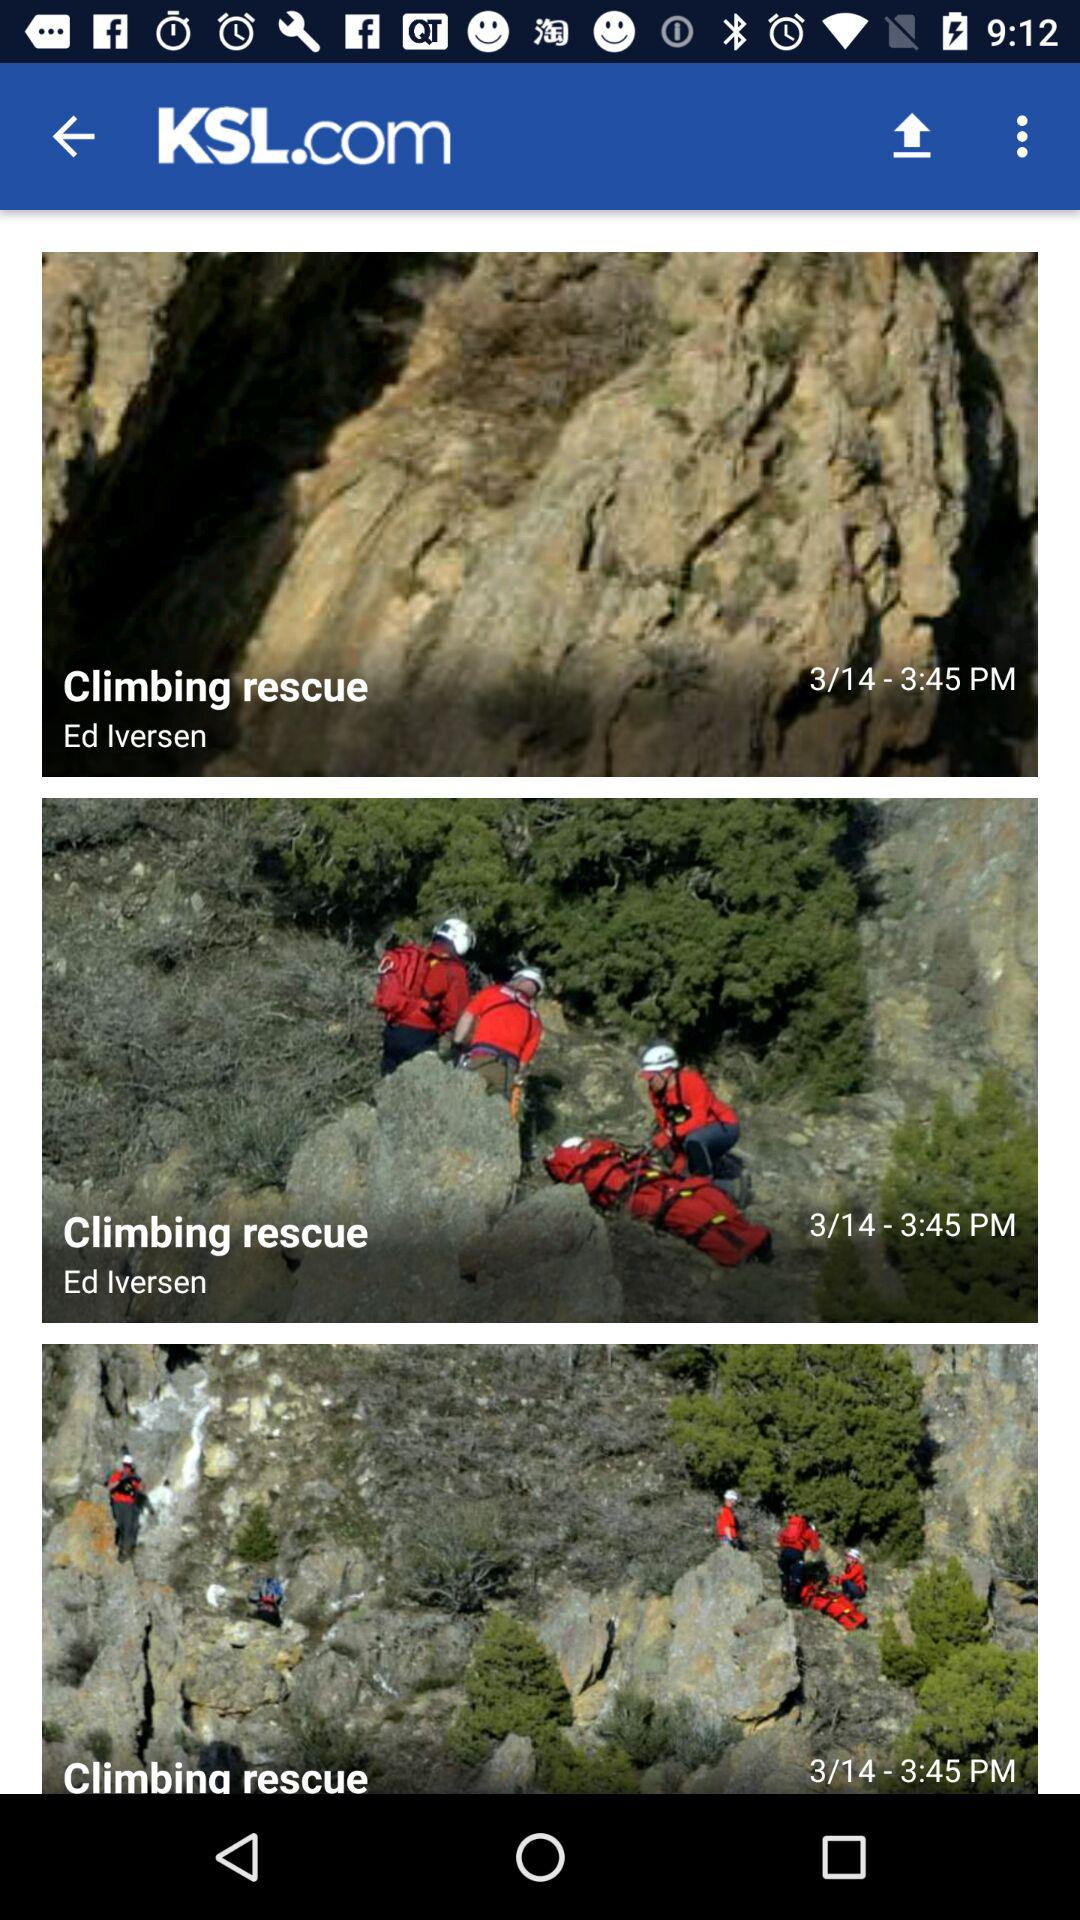What is the name of the application? The name of the application is "KSL News - Utah breaking news, weather, and sports". 